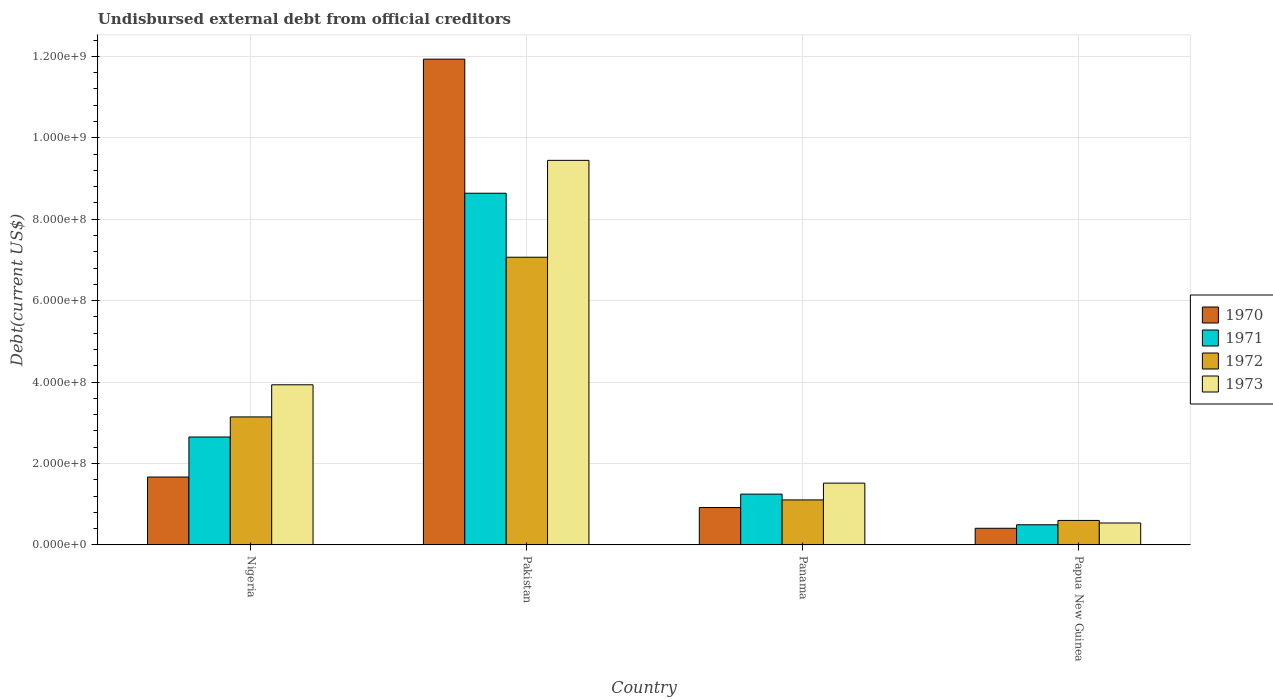How many different coloured bars are there?
Offer a terse response. 4. How many groups of bars are there?
Give a very brief answer. 4. Are the number of bars on each tick of the X-axis equal?
Provide a short and direct response. Yes. How many bars are there on the 4th tick from the right?
Make the answer very short. 4. What is the label of the 1st group of bars from the left?
Provide a short and direct response. Nigeria. In how many cases, is the number of bars for a given country not equal to the number of legend labels?
Keep it short and to the point. 0. What is the total debt in 1972 in Pakistan?
Offer a terse response. 7.07e+08. Across all countries, what is the maximum total debt in 1970?
Offer a terse response. 1.19e+09. Across all countries, what is the minimum total debt in 1970?
Keep it short and to the point. 4.09e+07. In which country was the total debt in 1972 maximum?
Your answer should be compact. Pakistan. In which country was the total debt in 1970 minimum?
Offer a terse response. Papua New Guinea. What is the total total debt in 1972 in the graph?
Your answer should be very brief. 1.19e+09. What is the difference between the total debt in 1970 in Nigeria and that in Pakistan?
Provide a succinct answer. -1.03e+09. What is the difference between the total debt in 1970 in Nigeria and the total debt in 1973 in Pakistan?
Provide a succinct answer. -7.78e+08. What is the average total debt in 1971 per country?
Provide a succinct answer. 3.26e+08. What is the difference between the total debt of/in 1971 and total debt of/in 1970 in Papua New Guinea?
Your answer should be very brief. 8.56e+06. What is the ratio of the total debt in 1970 in Pakistan to that in Papua New Guinea?
Offer a terse response. 29.15. Is the total debt in 1972 in Pakistan less than that in Papua New Guinea?
Offer a terse response. No. What is the difference between the highest and the second highest total debt in 1971?
Give a very brief answer. 7.39e+08. What is the difference between the highest and the lowest total debt in 1972?
Provide a succinct answer. 6.46e+08. What does the 1st bar from the right in Papua New Guinea represents?
Ensure brevity in your answer.  1973. Are all the bars in the graph horizontal?
Your answer should be very brief. No. How many countries are there in the graph?
Provide a succinct answer. 4. What is the difference between two consecutive major ticks on the Y-axis?
Offer a terse response. 2.00e+08. Are the values on the major ticks of Y-axis written in scientific E-notation?
Offer a very short reply. Yes. Does the graph contain grids?
Your response must be concise. Yes. Where does the legend appear in the graph?
Ensure brevity in your answer.  Center right. What is the title of the graph?
Your answer should be very brief. Undisbursed external debt from official creditors. Does "2014" appear as one of the legend labels in the graph?
Your answer should be compact. No. What is the label or title of the Y-axis?
Ensure brevity in your answer.  Debt(current US$). What is the Debt(current US$) of 1970 in Nigeria?
Ensure brevity in your answer.  1.67e+08. What is the Debt(current US$) in 1971 in Nigeria?
Offer a very short reply. 2.65e+08. What is the Debt(current US$) in 1972 in Nigeria?
Make the answer very short. 3.14e+08. What is the Debt(current US$) in 1973 in Nigeria?
Offer a terse response. 3.93e+08. What is the Debt(current US$) in 1970 in Pakistan?
Provide a succinct answer. 1.19e+09. What is the Debt(current US$) of 1971 in Pakistan?
Provide a succinct answer. 8.64e+08. What is the Debt(current US$) of 1972 in Pakistan?
Give a very brief answer. 7.07e+08. What is the Debt(current US$) of 1973 in Pakistan?
Keep it short and to the point. 9.44e+08. What is the Debt(current US$) in 1970 in Panama?
Offer a very short reply. 9.19e+07. What is the Debt(current US$) in 1971 in Panama?
Make the answer very short. 1.25e+08. What is the Debt(current US$) in 1972 in Panama?
Provide a short and direct response. 1.11e+08. What is the Debt(current US$) of 1973 in Panama?
Provide a short and direct response. 1.52e+08. What is the Debt(current US$) of 1970 in Papua New Guinea?
Your answer should be very brief. 4.09e+07. What is the Debt(current US$) in 1971 in Papua New Guinea?
Your answer should be compact. 4.95e+07. What is the Debt(current US$) in 1972 in Papua New Guinea?
Provide a short and direct response. 6.02e+07. What is the Debt(current US$) of 1973 in Papua New Guinea?
Provide a short and direct response. 5.39e+07. Across all countries, what is the maximum Debt(current US$) of 1970?
Your answer should be compact. 1.19e+09. Across all countries, what is the maximum Debt(current US$) in 1971?
Your response must be concise. 8.64e+08. Across all countries, what is the maximum Debt(current US$) of 1972?
Ensure brevity in your answer.  7.07e+08. Across all countries, what is the maximum Debt(current US$) of 1973?
Offer a terse response. 9.44e+08. Across all countries, what is the minimum Debt(current US$) of 1970?
Offer a very short reply. 4.09e+07. Across all countries, what is the minimum Debt(current US$) in 1971?
Your answer should be compact. 4.95e+07. Across all countries, what is the minimum Debt(current US$) in 1972?
Give a very brief answer. 6.02e+07. Across all countries, what is the minimum Debt(current US$) of 1973?
Keep it short and to the point. 5.39e+07. What is the total Debt(current US$) of 1970 in the graph?
Your answer should be very brief. 1.49e+09. What is the total Debt(current US$) in 1971 in the graph?
Ensure brevity in your answer.  1.30e+09. What is the total Debt(current US$) of 1972 in the graph?
Make the answer very short. 1.19e+09. What is the total Debt(current US$) of 1973 in the graph?
Make the answer very short. 1.54e+09. What is the difference between the Debt(current US$) in 1970 in Nigeria and that in Pakistan?
Your response must be concise. -1.03e+09. What is the difference between the Debt(current US$) in 1971 in Nigeria and that in Pakistan?
Offer a terse response. -5.99e+08. What is the difference between the Debt(current US$) in 1972 in Nigeria and that in Pakistan?
Make the answer very short. -3.92e+08. What is the difference between the Debt(current US$) of 1973 in Nigeria and that in Pakistan?
Your answer should be compact. -5.51e+08. What is the difference between the Debt(current US$) in 1970 in Nigeria and that in Panama?
Your response must be concise. 7.49e+07. What is the difference between the Debt(current US$) in 1971 in Nigeria and that in Panama?
Offer a very short reply. 1.40e+08. What is the difference between the Debt(current US$) in 1972 in Nigeria and that in Panama?
Provide a succinct answer. 2.04e+08. What is the difference between the Debt(current US$) of 1973 in Nigeria and that in Panama?
Offer a terse response. 2.41e+08. What is the difference between the Debt(current US$) in 1970 in Nigeria and that in Papua New Guinea?
Offer a terse response. 1.26e+08. What is the difference between the Debt(current US$) of 1971 in Nigeria and that in Papua New Guinea?
Make the answer very short. 2.16e+08. What is the difference between the Debt(current US$) of 1972 in Nigeria and that in Papua New Guinea?
Your answer should be very brief. 2.54e+08. What is the difference between the Debt(current US$) in 1973 in Nigeria and that in Papua New Guinea?
Your response must be concise. 3.39e+08. What is the difference between the Debt(current US$) of 1970 in Pakistan and that in Panama?
Ensure brevity in your answer.  1.10e+09. What is the difference between the Debt(current US$) of 1971 in Pakistan and that in Panama?
Provide a succinct answer. 7.39e+08. What is the difference between the Debt(current US$) of 1972 in Pakistan and that in Panama?
Keep it short and to the point. 5.96e+08. What is the difference between the Debt(current US$) in 1973 in Pakistan and that in Panama?
Offer a terse response. 7.93e+08. What is the difference between the Debt(current US$) of 1970 in Pakistan and that in Papua New Guinea?
Provide a succinct answer. 1.15e+09. What is the difference between the Debt(current US$) in 1971 in Pakistan and that in Papua New Guinea?
Give a very brief answer. 8.14e+08. What is the difference between the Debt(current US$) in 1972 in Pakistan and that in Papua New Guinea?
Ensure brevity in your answer.  6.46e+08. What is the difference between the Debt(current US$) of 1973 in Pakistan and that in Papua New Guinea?
Offer a terse response. 8.91e+08. What is the difference between the Debt(current US$) in 1970 in Panama and that in Papua New Guinea?
Your response must be concise. 5.10e+07. What is the difference between the Debt(current US$) of 1971 in Panama and that in Papua New Guinea?
Keep it short and to the point. 7.53e+07. What is the difference between the Debt(current US$) in 1972 in Panama and that in Papua New Guinea?
Make the answer very short. 5.04e+07. What is the difference between the Debt(current US$) of 1973 in Panama and that in Papua New Guinea?
Give a very brief answer. 9.79e+07. What is the difference between the Debt(current US$) of 1970 in Nigeria and the Debt(current US$) of 1971 in Pakistan?
Your response must be concise. -6.97e+08. What is the difference between the Debt(current US$) of 1970 in Nigeria and the Debt(current US$) of 1972 in Pakistan?
Keep it short and to the point. -5.40e+08. What is the difference between the Debt(current US$) in 1970 in Nigeria and the Debt(current US$) in 1973 in Pakistan?
Offer a terse response. -7.78e+08. What is the difference between the Debt(current US$) in 1971 in Nigeria and the Debt(current US$) in 1972 in Pakistan?
Offer a very short reply. -4.42e+08. What is the difference between the Debt(current US$) in 1971 in Nigeria and the Debt(current US$) in 1973 in Pakistan?
Offer a very short reply. -6.79e+08. What is the difference between the Debt(current US$) in 1972 in Nigeria and the Debt(current US$) in 1973 in Pakistan?
Offer a terse response. -6.30e+08. What is the difference between the Debt(current US$) of 1970 in Nigeria and the Debt(current US$) of 1971 in Panama?
Offer a very short reply. 4.20e+07. What is the difference between the Debt(current US$) of 1970 in Nigeria and the Debt(current US$) of 1972 in Panama?
Your response must be concise. 5.62e+07. What is the difference between the Debt(current US$) of 1970 in Nigeria and the Debt(current US$) of 1973 in Panama?
Offer a terse response. 1.50e+07. What is the difference between the Debt(current US$) of 1971 in Nigeria and the Debt(current US$) of 1972 in Panama?
Keep it short and to the point. 1.54e+08. What is the difference between the Debt(current US$) of 1971 in Nigeria and the Debt(current US$) of 1973 in Panama?
Keep it short and to the point. 1.13e+08. What is the difference between the Debt(current US$) in 1972 in Nigeria and the Debt(current US$) in 1973 in Panama?
Your response must be concise. 1.63e+08. What is the difference between the Debt(current US$) of 1970 in Nigeria and the Debt(current US$) of 1971 in Papua New Guinea?
Ensure brevity in your answer.  1.17e+08. What is the difference between the Debt(current US$) of 1970 in Nigeria and the Debt(current US$) of 1972 in Papua New Guinea?
Ensure brevity in your answer.  1.07e+08. What is the difference between the Debt(current US$) in 1970 in Nigeria and the Debt(current US$) in 1973 in Papua New Guinea?
Your answer should be very brief. 1.13e+08. What is the difference between the Debt(current US$) of 1971 in Nigeria and the Debt(current US$) of 1972 in Papua New Guinea?
Give a very brief answer. 2.05e+08. What is the difference between the Debt(current US$) in 1971 in Nigeria and the Debt(current US$) in 1973 in Papua New Guinea?
Your answer should be very brief. 2.11e+08. What is the difference between the Debt(current US$) of 1972 in Nigeria and the Debt(current US$) of 1973 in Papua New Guinea?
Give a very brief answer. 2.61e+08. What is the difference between the Debt(current US$) in 1970 in Pakistan and the Debt(current US$) in 1971 in Panama?
Give a very brief answer. 1.07e+09. What is the difference between the Debt(current US$) in 1970 in Pakistan and the Debt(current US$) in 1972 in Panama?
Your answer should be very brief. 1.08e+09. What is the difference between the Debt(current US$) of 1970 in Pakistan and the Debt(current US$) of 1973 in Panama?
Provide a short and direct response. 1.04e+09. What is the difference between the Debt(current US$) of 1971 in Pakistan and the Debt(current US$) of 1972 in Panama?
Ensure brevity in your answer.  7.53e+08. What is the difference between the Debt(current US$) of 1971 in Pakistan and the Debt(current US$) of 1973 in Panama?
Offer a very short reply. 7.12e+08. What is the difference between the Debt(current US$) in 1972 in Pakistan and the Debt(current US$) in 1973 in Panama?
Provide a short and direct response. 5.55e+08. What is the difference between the Debt(current US$) of 1970 in Pakistan and the Debt(current US$) of 1971 in Papua New Guinea?
Offer a very short reply. 1.14e+09. What is the difference between the Debt(current US$) of 1970 in Pakistan and the Debt(current US$) of 1972 in Papua New Guinea?
Your response must be concise. 1.13e+09. What is the difference between the Debt(current US$) of 1970 in Pakistan and the Debt(current US$) of 1973 in Papua New Guinea?
Your answer should be very brief. 1.14e+09. What is the difference between the Debt(current US$) of 1971 in Pakistan and the Debt(current US$) of 1972 in Papua New Guinea?
Ensure brevity in your answer.  8.04e+08. What is the difference between the Debt(current US$) of 1971 in Pakistan and the Debt(current US$) of 1973 in Papua New Guinea?
Offer a very short reply. 8.10e+08. What is the difference between the Debt(current US$) in 1972 in Pakistan and the Debt(current US$) in 1973 in Papua New Guinea?
Your answer should be very brief. 6.53e+08. What is the difference between the Debt(current US$) of 1970 in Panama and the Debt(current US$) of 1971 in Papua New Guinea?
Your answer should be very brief. 4.24e+07. What is the difference between the Debt(current US$) in 1970 in Panama and the Debt(current US$) in 1972 in Papua New Guinea?
Your answer should be very brief. 3.17e+07. What is the difference between the Debt(current US$) of 1970 in Panama and the Debt(current US$) of 1973 in Papua New Guinea?
Keep it short and to the point. 3.80e+07. What is the difference between the Debt(current US$) of 1971 in Panama and the Debt(current US$) of 1972 in Papua New Guinea?
Provide a succinct answer. 6.46e+07. What is the difference between the Debt(current US$) in 1971 in Panama and the Debt(current US$) in 1973 in Papua New Guinea?
Provide a short and direct response. 7.09e+07. What is the difference between the Debt(current US$) in 1972 in Panama and the Debt(current US$) in 1973 in Papua New Guinea?
Provide a short and direct response. 5.67e+07. What is the average Debt(current US$) of 1970 per country?
Your answer should be compact. 3.73e+08. What is the average Debt(current US$) in 1971 per country?
Keep it short and to the point. 3.26e+08. What is the average Debt(current US$) in 1972 per country?
Provide a short and direct response. 2.98e+08. What is the average Debt(current US$) of 1973 per country?
Provide a succinct answer. 3.86e+08. What is the difference between the Debt(current US$) in 1970 and Debt(current US$) in 1971 in Nigeria?
Give a very brief answer. -9.83e+07. What is the difference between the Debt(current US$) in 1970 and Debt(current US$) in 1972 in Nigeria?
Your answer should be compact. -1.48e+08. What is the difference between the Debt(current US$) in 1970 and Debt(current US$) in 1973 in Nigeria?
Give a very brief answer. -2.27e+08. What is the difference between the Debt(current US$) of 1971 and Debt(current US$) of 1972 in Nigeria?
Your answer should be very brief. -4.93e+07. What is the difference between the Debt(current US$) in 1971 and Debt(current US$) in 1973 in Nigeria?
Offer a very short reply. -1.28e+08. What is the difference between the Debt(current US$) in 1972 and Debt(current US$) in 1973 in Nigeria?
Your answer should be compact. -7.89e+07. What is the difference between the Debt(current US$) of 1970 and Debt(current US$) of 1971 in Pakistan?
Provide a short and direct response. 3.29e+08. What is the difference between the Debt(current US$) of 1970 and Debt(current US$) of 1972 in Pakistan?
Offer a very short reply. 4.86e+08. What is the difference between the Debt(current US$) in 1970 and Debt(current US$) in 1973 in Pakistan?
Give a very brief answer. 2.49e+08. What is the difference between the Debt(current US$) of 1971 and Debt(current US$) of 1972 in Pakistan?
Keep it short and to the point. 1.57e+08. What is the difference between the Debt(current US$) of 1971 and Debt(current US$) of 1973 in Pakistan?
Your answer should be compact. -8.07e+07. What is the difference between the Debt(current US$) in 1972 and Debt(current US$) in 1973 in Pakistan?
Offer a very short reply. -2.38e+08. What is the difference between the Debt(current US$) in 1970 and Debt(current US$) in 1971 in Panama?
Give a very brief answer. -3.29e+07. What is the difference between the Debt(current US$) in 1970 and Debt(current US$) in 1972 in Panama?
Provide a succinct answer. -1.87e+07. What is the difference between the Debt(current US$) of 1970 and Debt(current US$) of 1973 in Panama?
Give a very brief answer. -5.99e+07. What is the difference between the Debt(current US$) of 1971 and Debt(current US$) of 1972 in Panama?
Offer a very short reply. 1.42e+07. What is the difference between the Debt(current US$) in 1971 and Debt(current US$) in 1973 in Panama?
Your answer should be very brief. -2.70e+07. What is the difference between the Debt(current US$) of 1972 and Debt(current US$) of 1973 in Panama?
Offer a terse response. -4.12e+07. What is the difference between the Debt(current US$) of 1970 and Debt(current US$) of 1971 in Papua New Guinea?
Ensure brevity in your answer.  -8.56e+06. What is the difference between the Debt(current US$) of 1970 and Debt(current US$) of 1972 in Papua New Guinea?
Your answer should be compact. -1.93e+07. What is the difference between the Debt(current US$) of 1970 and Debt(current US$) of 1973 in Papua New Guinea?
Offer a terse response. -1.29e+07. What is the difference between the Debt(current US$) of 1971 and Debt(current US$) of 1972 in Papua New Guinea?
Make the answer very short. -1.07e+07. What is the difference between the Debt(current US$) in 1971 and Debt(current US$) in 1973 in Papua New Guinea?
Provide a succinct answer. -4.38e+06. What is the difference between the Debt(current US$) in 1972 and Debt(current US$) in 1973 in Papua New Guinea?
Make the answer very short. 6.30e+06. What is the ratio of the Debt(current US$) in 1970 in Nigeria to that in Pakistan?
Offer a very short reply. 0.14. What is the ratio of the Debt(current US$) of 1971 in Nigeria to that in Pakistan?
Keep it short and to the point. 0.31. What is the ratio of the Debt(current US$) of 1972 in Nigeria to that in Pakistan?
Provide a succinct answer. 0.45. What is the ratio of the Debt(current US$) of 1973 in Nigeria to that in Pakistan?
Give a very brief answer. 0.42. What is the ratio of the Debt(current US$) of 1970 in Nigeria to that in Panama?
Keep it short and to the point. 1.81. What is the ratio of the Debt(current US$) of 1971 in Nigeria to that in Panama?
Your response must be concise. 2.12. What is the ratio of the Debt(current US$) of 1972 in Nigeria to that in Panama?
Keep it short and to the point. 2.84. What is the ratio of the Debt(current US$) of 1973 in Nigeria to that in Panama?
Provide a succinct answer. 2.59. What is the ratio of the Debt(current US$) of 1970 in Nigeria to that in Papua New Guinea?
Offer a terse response. 4.07. What is the ratio of the Debt(current US$) of 1971 in Nigeria to that in Papua New Guinea?
Provide a short and direct response. 5.36. What is the ratio of the Debt(current US$) of 1972 in Nigeria to that in Papua New Guinea?
Your response must be concise. 5.22. What is the ratio of the Debt(current US$) of 1973 in Nigeria to that in Papua New Guinea?
Give a very brief answer. 7.3. What is the ratio of the Debt(current US$) of 1970 in Pakistan to that in Panama?
Ensure brevity in your answer.  12.98. What is the ratio of the Debt(current US$) in 1971 in Pakistan to that in Panama?
Keep it short and to the point. 6.92. What is the ratio of the Debt(current US$) of 1972 in Pakistan to that in Panama?
Ensure brevity in your answer.  6.39. What is the ratio of the Debt(current US$) in 1973 in Pakistan to that in Panama?
Offer a very short reply. 6.22. What is the ratio of the Debt(current US$) in 1970 in Pakistan to that in Papua New Guinea?
Ensure brevity in your answer.  29.15. What is the ratio of the Debt(current US$) in 1971 in Pakistan to that in Papua New Guinea?
Offer a terse response. 17.45. What is the ratio of the Debt(current US$) of 1972 in Pakistan to that in Papua New Guinea?
Offer a very short reply. 11.74. What is the ratio of the Debt(current US$) of 1973 in Pakistan to that in Papua New Guinea?
Your answer should be compact. 17.53. What is the ratio of the Debt(current US$) of 1970 in Panama to that in Papua New Guinea?
Provide a succinct answer. 2.24. What is the ratio of the Debt(current US$) in 1971 in Panama to that in Papua New Guinea?
Ensure brevity in your answer.  2.52. What is the ratio of the Debt(current US$) in 1972 in Panama to that in Papua New Guinea?
Offer a terse response. 1.84. What is the ratio of the Debt(current US$) of 1973 in Panama to that in Papua New Guinea?
Your answer should be compact. 2.82. What is the difference between the highest and the second highest Debt(current US$) in 1970?
Your response must be concise. 1.03e+09. What is the difference between the highest and the second highest Debt(current US$) in 1971?
Ensure brevity in your answer.  5.99e+08. What is the difference between the highest and the second highest Debt(current US$) of 1972?
Your answer should be very brief. 3.92e+08. What is the difference between the highest and the second highest Debt(current US$) in 1973?
Offer a terse response. 5.51e+08. What is the difference between the highest and the lowest Debt(current US$) in 1970?
Keep it short and to the point. 1.15e+09. What is the difference between the highest and the lowest Debt(current US$) of 1971?
Your response must be concise. 8.14e+08. What is the difference between the highest and the lowest Debt(current US$) of 1972?
Your answer should be compact. 6.46e+08. What is the difference between the highest and the lowest Debt(current US$) in 1973?
Offer a terse response. 8.91e+08. 